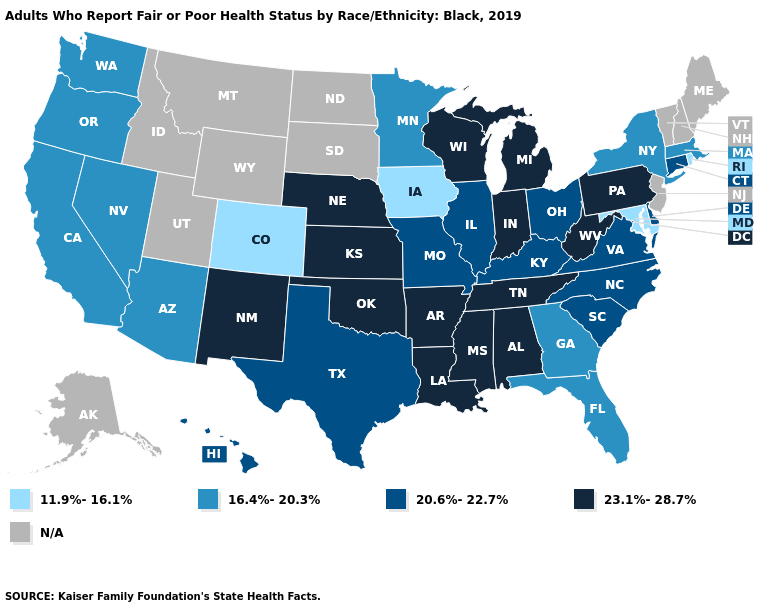What is the lowest value in states that border New Hampshire?
Give a very brief answer. 16.4%-20.3%. Name the states that have a value in the range 16.4%-20.3%?
Keep it brief. Arizona, California, Florida, Georgia, Massachusetts, Minnesota, Nevada, New York, Oregon, Washington. What is the value of Texas?
Concise answer only. 20.6%-22.7%. Name the states that have a value in the range 20.6%-22.7%?
Short answer required. Connecticut, Delaware, Hawaii, Illinois, Kentucky, Missouri, North Carolina, Ohio, South Carolina, Texas, Virginia. Is the legend a continuous bar?
Answer briefly. No. Which states have the lowest value in the Northeast?
Short answer required. Rhode Island. Name the states that have a value in the range 20.6%-22.7%?
Give a very brief answer. Connecticut, Delaware, Hawaii, Illinois, Kentucky, Missouri, North Carolina, Ohio, South Carolina, Texas, Virginia. Which states have the highest value in the USA?
Write a very short answer. Alabama, Arkansas, Indiana, Kansas, Louisiana, Michigan, Mississippi, Nebraska, New Mexico, Oklahoma, Pennsylvania, Tennessee, West Virginia, Wisconsin. Name the states that have a value in the range 20.6%-22.7%?
Keep it brief. Connecticut, Delaware, Hawaii, Illinois, Kentucky, Missouri, North Carolina, Ohio, South Carolina, Texas, Virginia. What is the lowest value in states that border Iowa?
Answer briefly. 16.4%-20.3%. Name the states that have a value in the range 23.1%-28.7%?
Keep it brief. Alabama, Arkansas, Indiana, Kansas, Louisiana, Michigan, Mississippi, Nebraska, New Mexico, Oklahoma, Pennsylvania, Tennessee, West Virginia, Wisconsin. What is the highest value in the Northeast ?
Concise answer only. 23.1%-28.7%. Does Arizona have the highest value in the USA?
Write a very short answer. No. What is the lowest value in the West?
Write a very short answer. 11.9%-16.1%. 